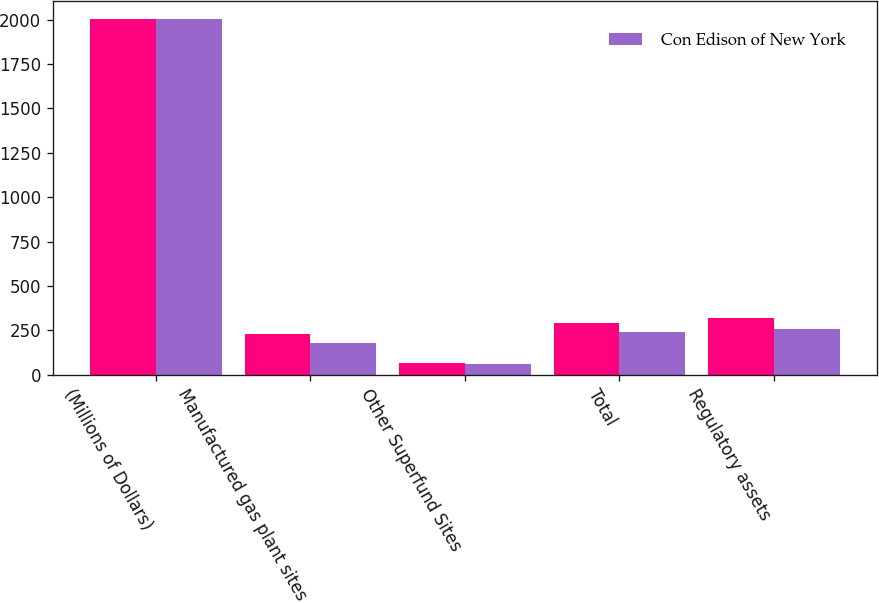Convert chart to OTSL. <chart><loc_0><loc_0><loc_500><loc_500><stacked_bar_chart><ecel><fcel>(Millions of Dollars)<fcel>Manufactured gas plant sites<fcel>Other Superfund Sites<fcel>Total<fcel>Regulatory assets<nl><fcel>nan<fcel>2006<fcel>228<fcel>64<fcel>292<fcel>318<nl><fcel>Con Edison of New York<fcel>2006<fcel>180<fcel>63<fcel>243<fcel>255<nl></chart> 